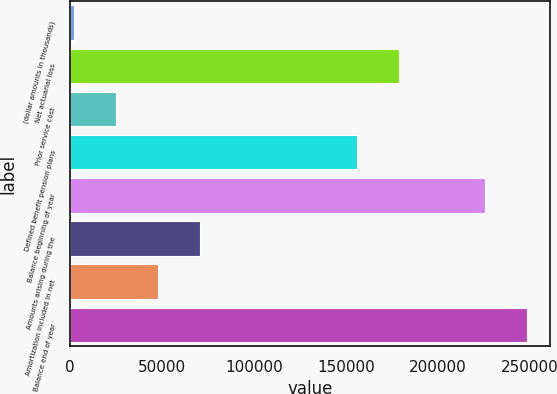<chart> <loc_0><loc_0><loc_500><loc_500><bar_chart><fcel>(dollar amounts in thousands)<fcel>Net actuarial loss<fcel>Prior service cost<fcel>Defined benefit pension plans<fcel>Balance beginning of year<fcel>Amounts arising during the<fcel>Amortization included in net<fcel>Balance end of year<nl><fcel>2013<fcel>179096<fcel>24886.4<fcel>156223<fcel>225680<fcel>70633.2<fcel>47759.8<fcel>248553<nl></chart> 